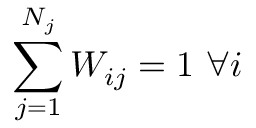Convert formula to latex. <formula><loc_0><loc_0><loc_500><loc_500>\sum _ { j = 1 } ^ { N _ { j } } W _ { i j } = 1 \ \forall i</formula> 